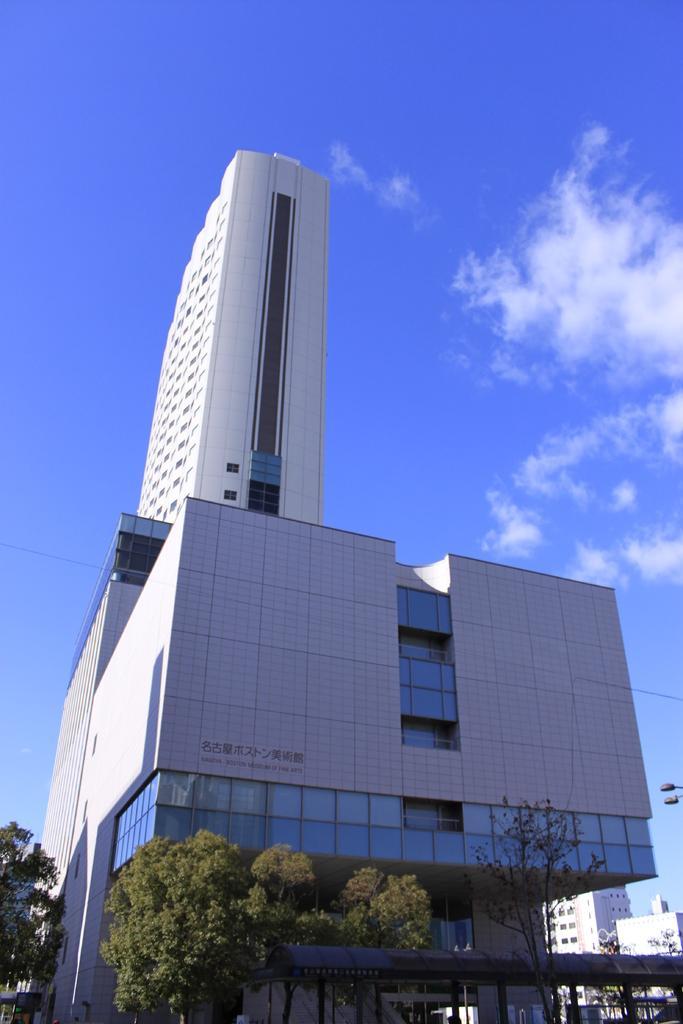Please provide a concise description of this image. In this picture we observe a building which has many glass windows and in the background we observe a white tower and there are few trees down the image. 